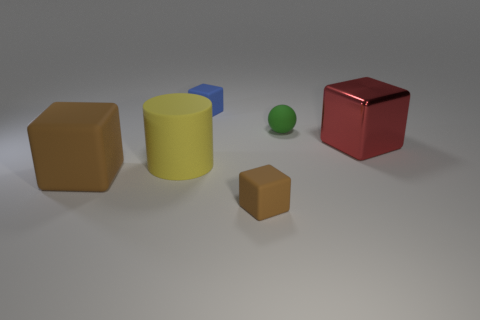Subtract all tiny blue cubes. How many cubes are left? 3 Subtract all cyan balls. How many brown cubes are left? 2 Subtract all red blocks. How many blocks are left? 3 Subtract all balls. How many objects are left? 5 Add 3 big brown balls. How many objects exist? 9 Subtract 0 brown balls. How many objects are left? 6 Subtract all blue blocks. Subtract all brown balls. How many blocks are left? 3 Subtract all cyan rubber things. Subtract all small things. How many objects are left? 3 Add 4 tiny rubber things. How many tiny rubber things are left? 7 Add 6 big yellow cylinders. How many big yellow cylinders exist? 7 